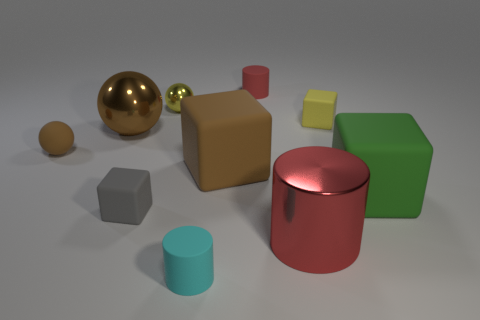Are there any other things that are the same shape as the large green rubber thing?
Your answer should be very brief. Yes. There is another sphere that is the same material as the yellow ball; what is its color?
Ensure brevity in your answer.  Brown. How many objects are either large brown objects or blue matte blocks?
Provide a short and direct response. 2. Do the green object and the yellow object on the right side of the red metallic cylinder have the same size?
Ensure brevity in your answer.  No. The cube that is in front of the large block that is right of the rubber block behind the brown rubber ball is what color?
Ensure brevity in your answer.  Gray. The big cylinder is what color?
Keep it short and to the point. Red. Are there more rubber blocks in front of the large brown cube than rubber cylinders behind the large green matte thing?
Ensure brevity in your answer.  Yes. There is a big brown metallic thing; is its shape the same as the small yellow thing on the right side of the large brown cube?
Give a very brief answer. No. There is a cyan matte cylinder that is in front of the big green object; is its size the same as the brown thing to the right of the yellow shiny thing?
Offer a very short reply. No. Are there any tiny matte spheres that are left of the brown object that is on the right side of the block that is to the left of the yellow shiny ball?
Your answer should be very brief. Yes. 